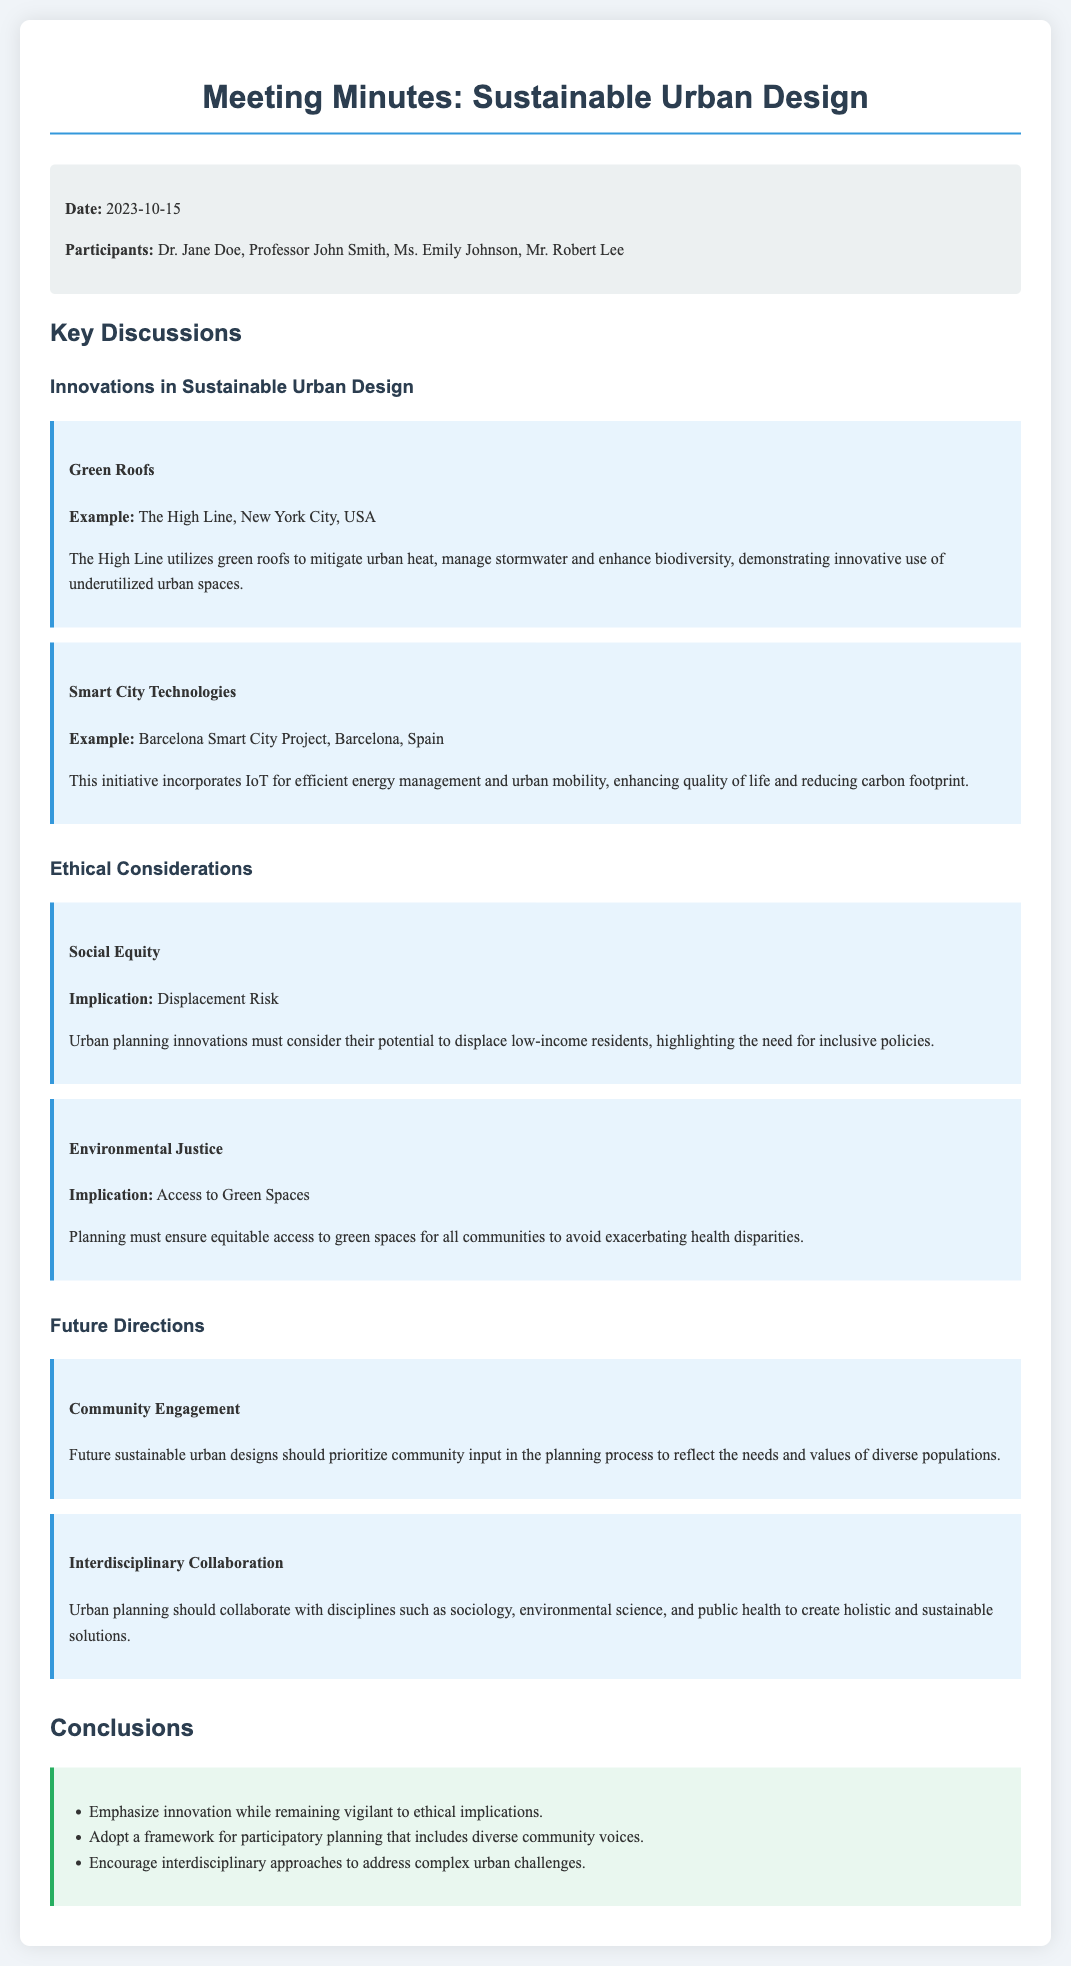What was the date of the meeting? The document specifies the meeting date as "2023-10-15".
Answer: 2023-10-15 Who was one of the participants? The document lists participants including Dr. Jane Doe.
Answer: Dr. Jane Doe What is an example of a green roof mentioned? The High Line is the example given for the use of green roofs.
Answer: The High Line What does the Barcelona Smart City Project focus on? The document mentions that it incorporates IoT for efficient energy management and urban mobility.
Answer: Efficient energy management and urban mobility What is a potential ethical implication related to social equity? The document states that innovations might lead to "displacement risk".
Answer: Displacement Risk What should future sustainable urban designs prioritize? The document highlights the importance of prioritizing "community input".
Answer: Community input Which interdisciplinary approach is suggested for urban planning? The document suggests collaboration with disciplines such as sociology and environmental science.
Answer: Sociology, environmental science What are the meeting minutes focused on? The minutes specifically address "Sustainable Urban Design".
Answer: Sustainable Urban Design What framework should be adopted according to the conclusions? The conclusions recommend a framework for "participatory planning".
Answer: Participatory planning 